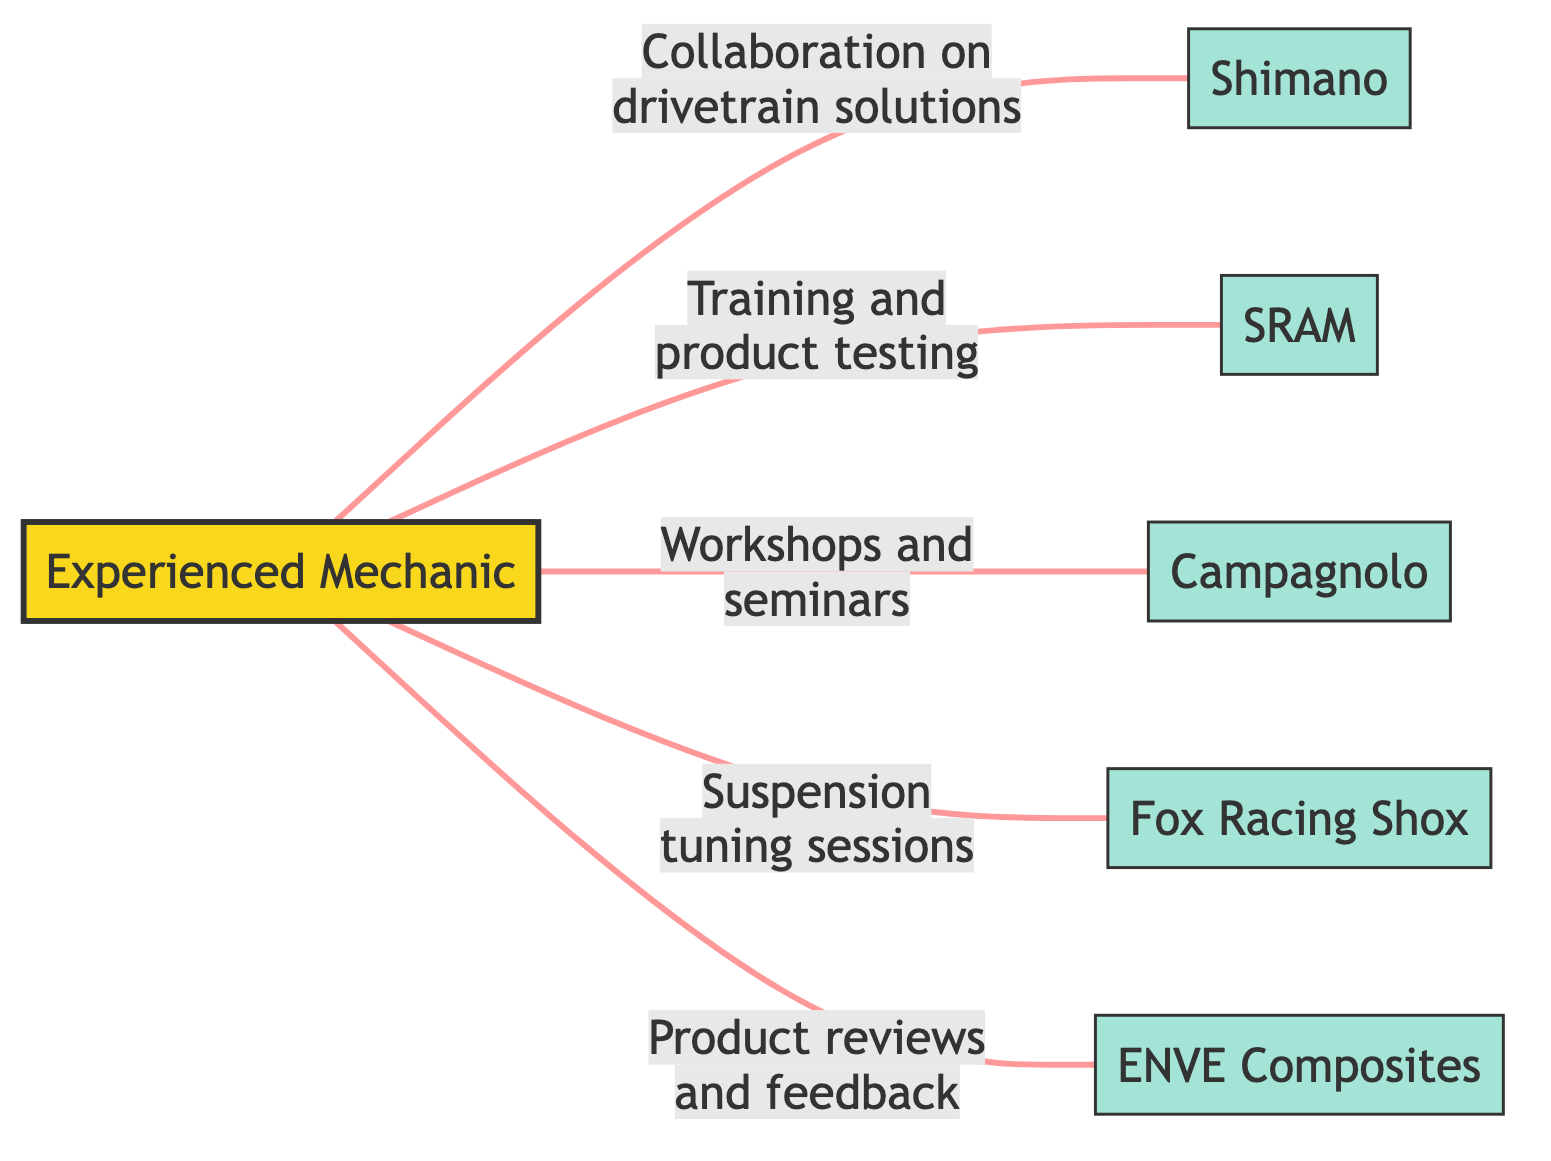What is the total number of nodes in the diagram? The diagram lists all the entities connected, which are the mechanic and five bike part manufacturers. Counting these, we have six nodes in total.
Answer: 6 Which manufacturer is associated with "Collaboration on drivetrain solutions"? The edge labeled "Collaboration on drivetrain solutions" connects the mechanic to Shimano, indicating this specific relationship.
Answer: Shimano How many training connections does the mechanic have? The mechanic is connected through training to one specific manufacturer, which is SRAM. This makes the total count of training-related connections equal to one.
Answer: 1 What type of event does the mechanic hold with Campagnolo? The mechanic conducts "Workshops and seminars" with Campagnolo, based on the information depicted in the edge label connecting them.
Answer: Workshops and seminars Which manufacturer is focused on suspension products? Fox Racing Shox is depicted in the diagram as the manufacturer that specializes in suspension products for bicycles.
Answer: Fox Racing Shox How many products does the mechanic review? The mechanic reviews one product line, specifically the carbon components from ENVE, as indicated in the edge labeled "Product reviews and feedback."
Answer: 1 Which node has the most collaboration edges connected to it? The mechanic is connected to five manufacturers, making it the central node with the most edges, while each manufacturer only connects back to one.
Answer: Mechanic What is the purpose of the connection between mechanic and SRAM? The purpose is described as "Training and product testing," which directly explains the relationship established in the edge label.
Answer: Training and product testing 